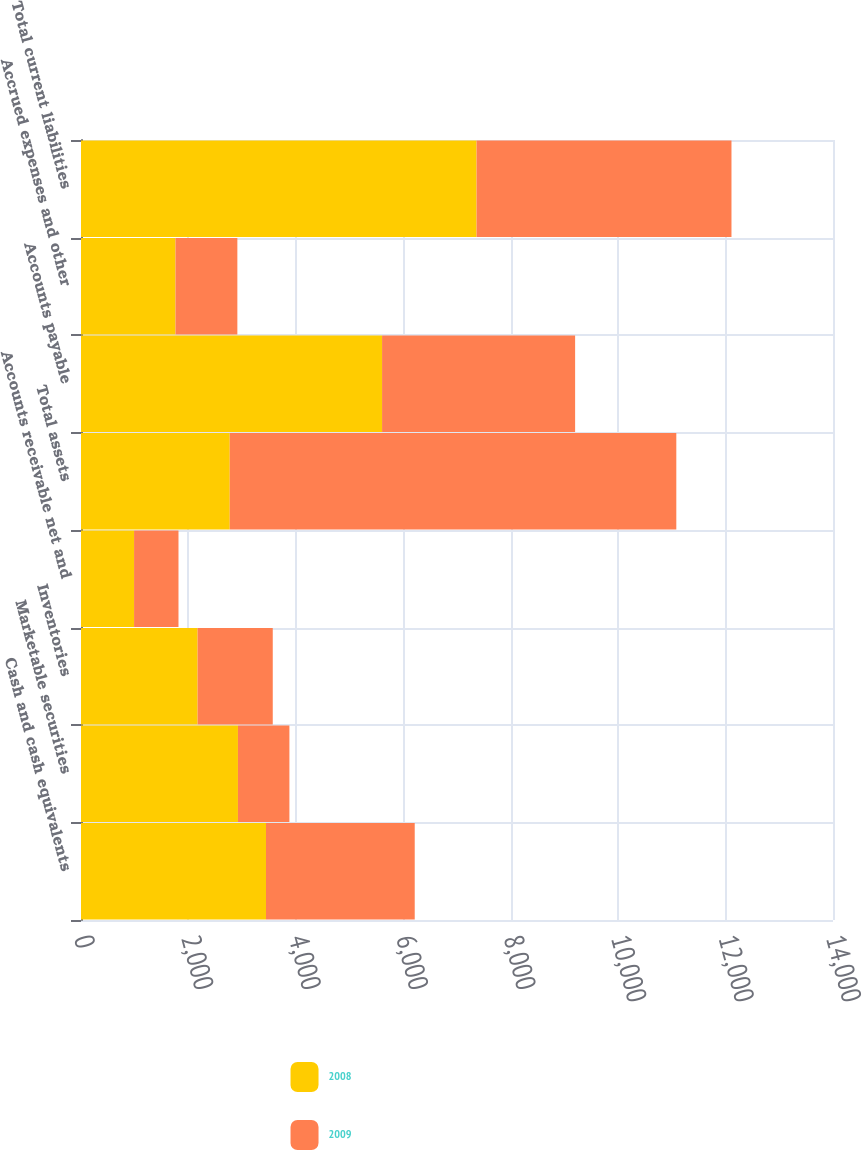Convert chart. <chart><loc_0><loc_0><loc_500><loc_500><stacked_bar_chart><ecel><fcel>Cash and cash equivalents<fcel>Marketable securities<fcel>Inventories<fcel>Accounts receivable net and<fcel>Total assets<fcel>Accounts payable<fcel>Accrued expenses and other<fcel>Total current liabilities<nl><fcel>2008<fcel>3444<fcel>2922<fcel>2171<fcel>988<fcel>2769<fcel>5605<fcel>1759<fcel>7364<nl><fcel>2009<fcel>2769<fcel>958<fcel>1399<fcel>827<fcel>8314<fcel>3594<fcel>1152<fcel>4746<nl></chart> 